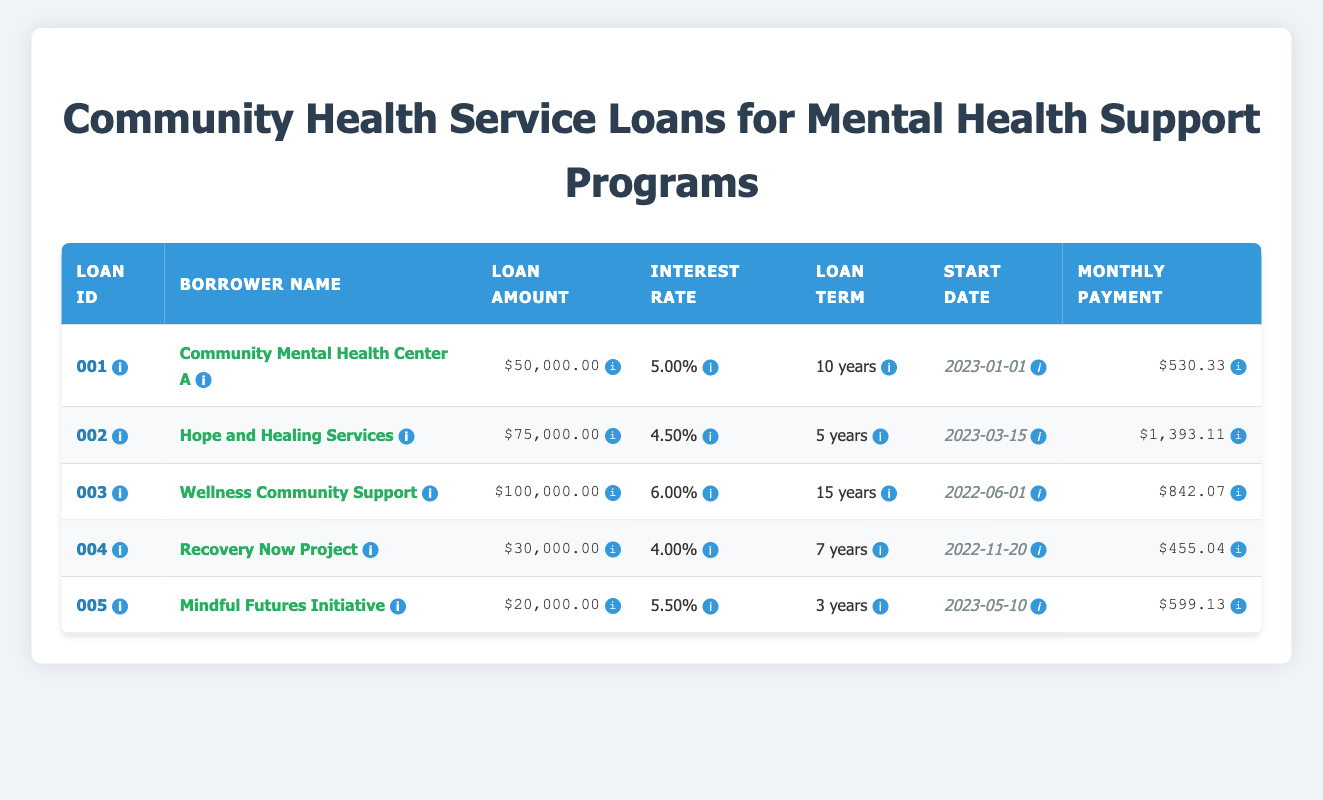What is the total loan amount for all the borrowers? To find the total loan amount, we add the loan amounts from all the borrowers: 50000 + 75000 + 100000 + 30000 + 20000 = 305000.
Answer: 305000 Which borrower has the highest monthly payment? Reviewing the monthly payments, Hope and Healing Services has the highest payment of 1393.11.
Answer: Hope and Healing Services Is the loan term for Mindful Futures Initiative shorter than that of Recovery Now Project? Mindful Futures Initiative has a loan term of 3 years, while Recovery Now Project has a term of 7 years. Since 3 is less than 7, the statement is true.
Answer: Yes How much total interest would be paid if all loans are paid off as scheduled? First, calculate the total payment for each loan: (monthly payment * number of months). For example, for loan 001, it's 530.33 * 120 = 63639.60. Next, calculate total payments for each and subtract the principal. The total interest would be: (63639.60 - 50000) + (83637.60 - 75000) + (151933.80 - 100000) + (38242.56 - 30000) + (21583.68 - 20000) = 82577.64.
Answer: 82577.64 What is the average monthly payment across all loans? To find the average, we sum all monthly payments: 530.33 + 1393.11 + 842.07 + 455.04 + 599.13 = 3819.68. Then, we divide by the number of loans: 3819.68 / 5 = 763.936.
Answer: 763.94 Is the annual interest rate for Community Mental Health Center A greater than 5 percent? The annual interest rate for Community Mental Health Center A is 5.00%, which is not greater than 5 percent, making the statement false.
Answer: No Which loan term is the longest among all the borrowers? By checking the loan terms, we see that Wellness Community Support has the longest loan term of 15 years.
Answer: Wellness Community Support 